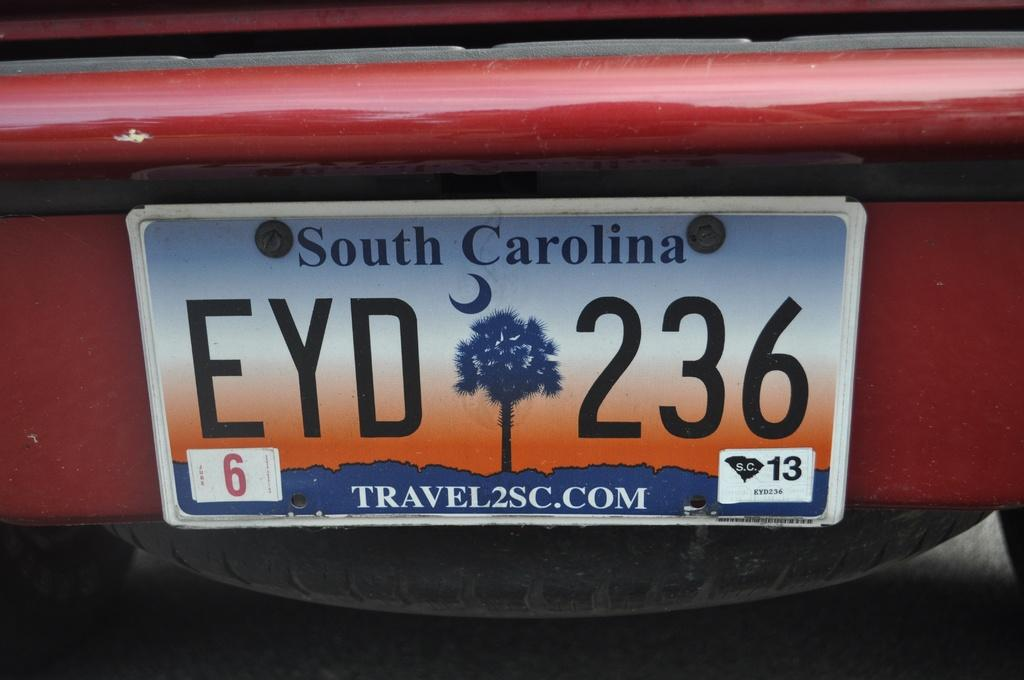<image>
Offer a succinct explanation of the picture presented. A South Carolina tag that reads EYD 236 on a red car. 